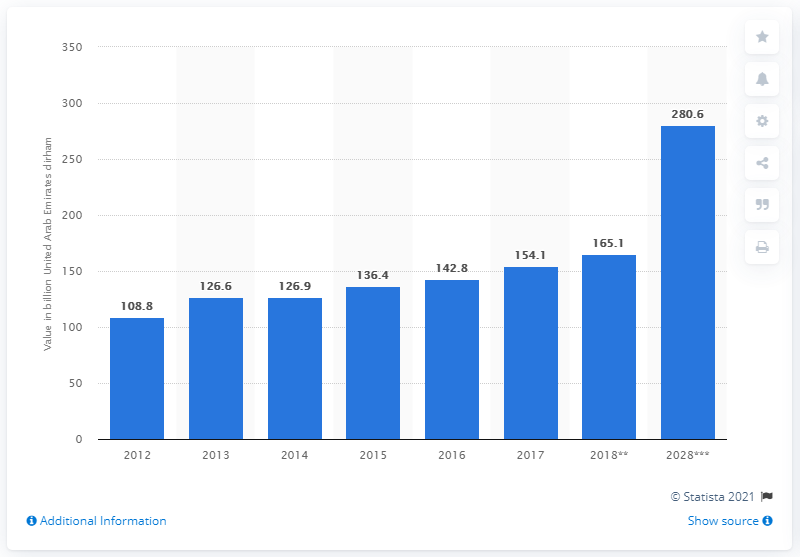Specify some key components in this picture. According to projections, tourism and travel are expected to contribute significantly to the Gross Domestic Product (GDP) of the UAE in 2028, with an estimated value of 280.6 billion dinars. 